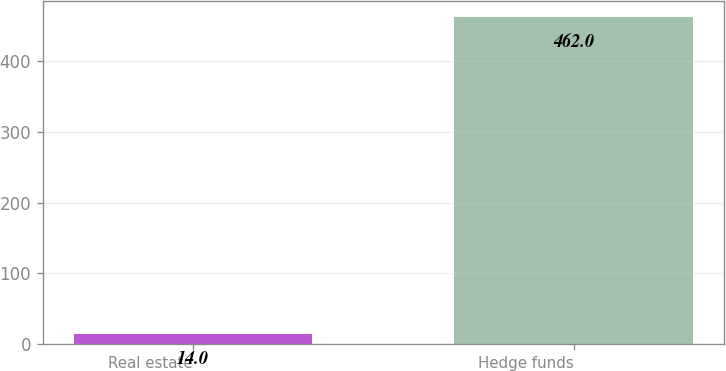<chart> <loc_0><loc_0><loc_500><loc_500><bar_chart><fcel>Real estate<fcel>Hedge funds<nl><fcel>14<fcel>462<nl></chart> 